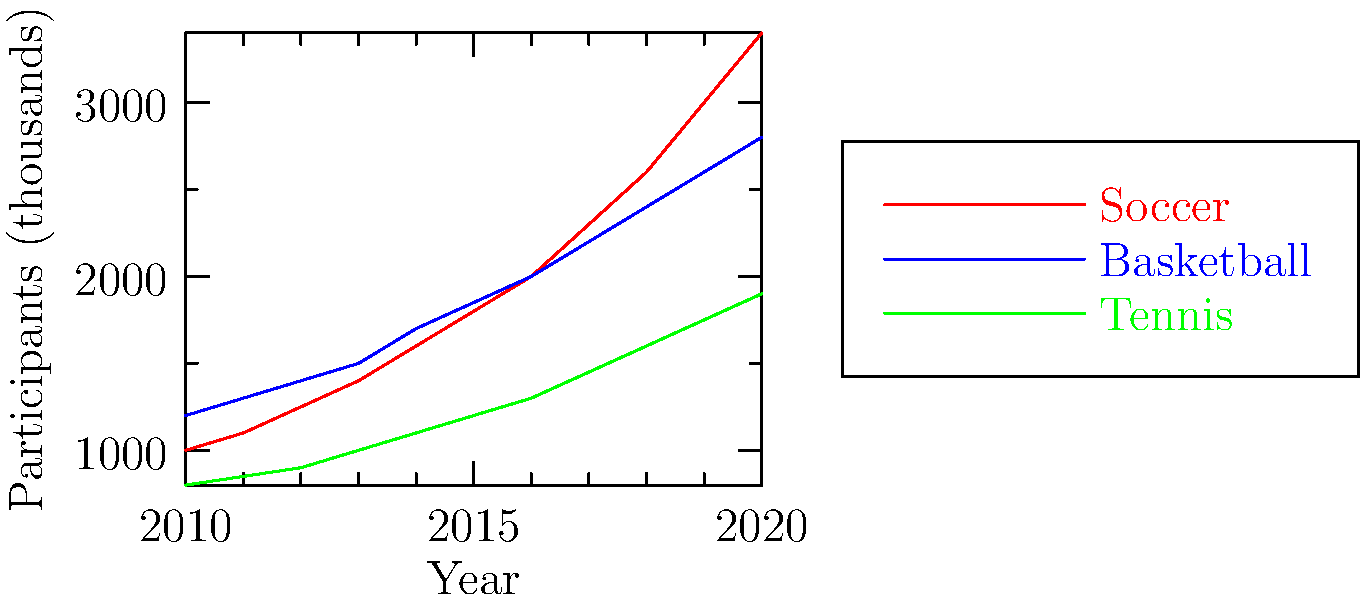Based on the line graph showing the growth of women's participation in different sports from 2010 to 2020, which sport experienced the highest percentage increase in participation over the decade? To determine which sport had the highest percentage increase, we need to calculate the percentage change for each sport from 2010 to 2020:

1. Soccer:
   - 2010 value: 1000 thousand
   - 2020 value: 3400 thousand
   - Percentage change = $\frac{3400 - 1000}{1000} \times 100\% = 240\%$

2. Basketball:
   - 2010 value: 1200 thousand
   - 2020 value: 2800 thousand
   - Percentage change = $\frac{2800 - 1200}{1200} \times 100\% = 133.33\%$

3. Tennis:
   - 2010 value: 800 thousand
   - 2020 value: 1900 thousand
   - Percentage change = $\frac{1900 - 800}{800} \times 100\% = 137.5\%$

Comparing these percentage increases, we can see that soccer had the highest percentage increase at 240%.
Answer: Soccer 